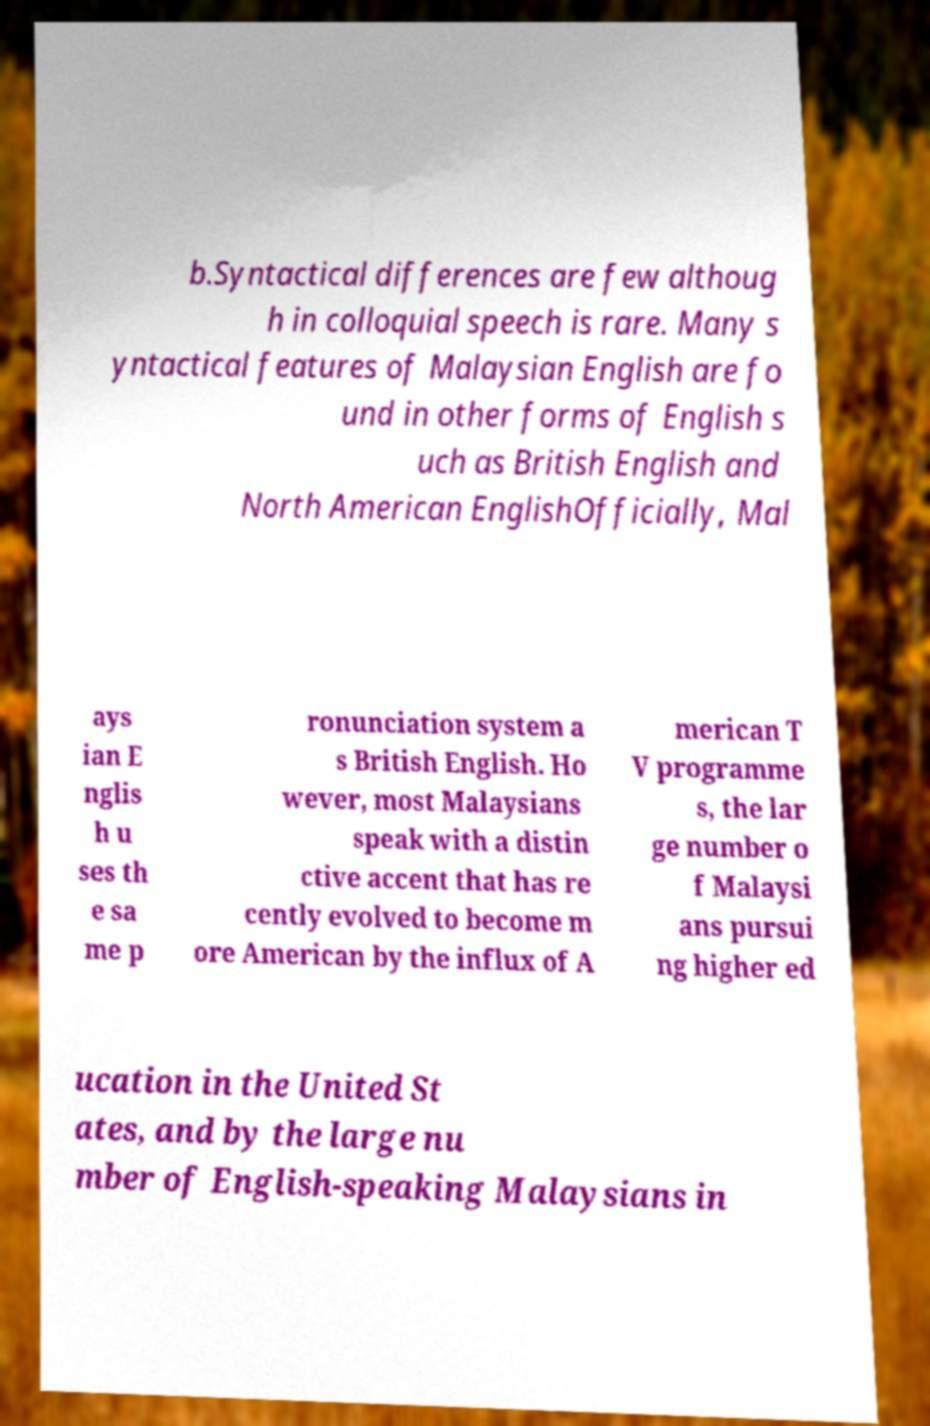Can you read and provide the text displayed in the image?This photo seems to have some interesting text. Can you extract and type it out for me? b.Syntactical differences are few althoug h in colloquial speech is rare. Many s yntactical features of Malaysian English are fo und in other forms of English s uch as British English and North American EnglishOfficially, Mal ays ian E nglis h u ses th e sa me p ronunciation system a s British English. Ho wever, most Malaysians speak with a distin ctive accent that has re cently evolved to become m ore American by the influx of A merican T V programme s, the lar ge number o f Malaysi ans pursui ng higher ed ucation in the United St ates, and by the large nu mber of English-speaking Malaysians in 